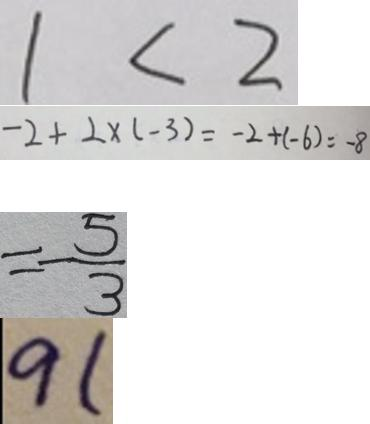Convert formula to latex. <formula><loc_0><loc_0><loc_500><loc_500>1 < 2 
 - 2 + 2 \times ( - 3 ) = - 2 + ( - 6 ) = - 8 
 = - \frac { 5 } { 3 } 
 9 1</formula> 